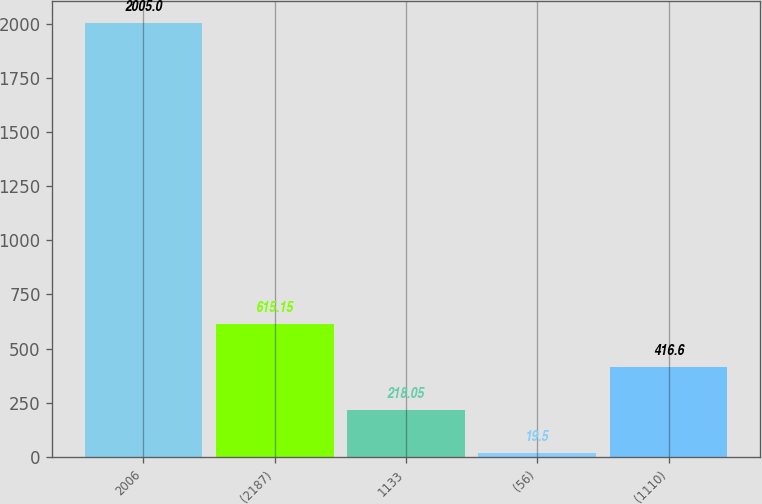Convert chart to OTSL. <chart><loc_0><loc_0><loc_500><loc_500><bar_chart><fcel>2006<fcel>(2187)<fcel>1133<fcel>(56)<fcel>(1110)<nl><fcel>2005<fcel>615.15<fcel>218.05<fcel>19.5<fcel>416.6<nl></chart> 